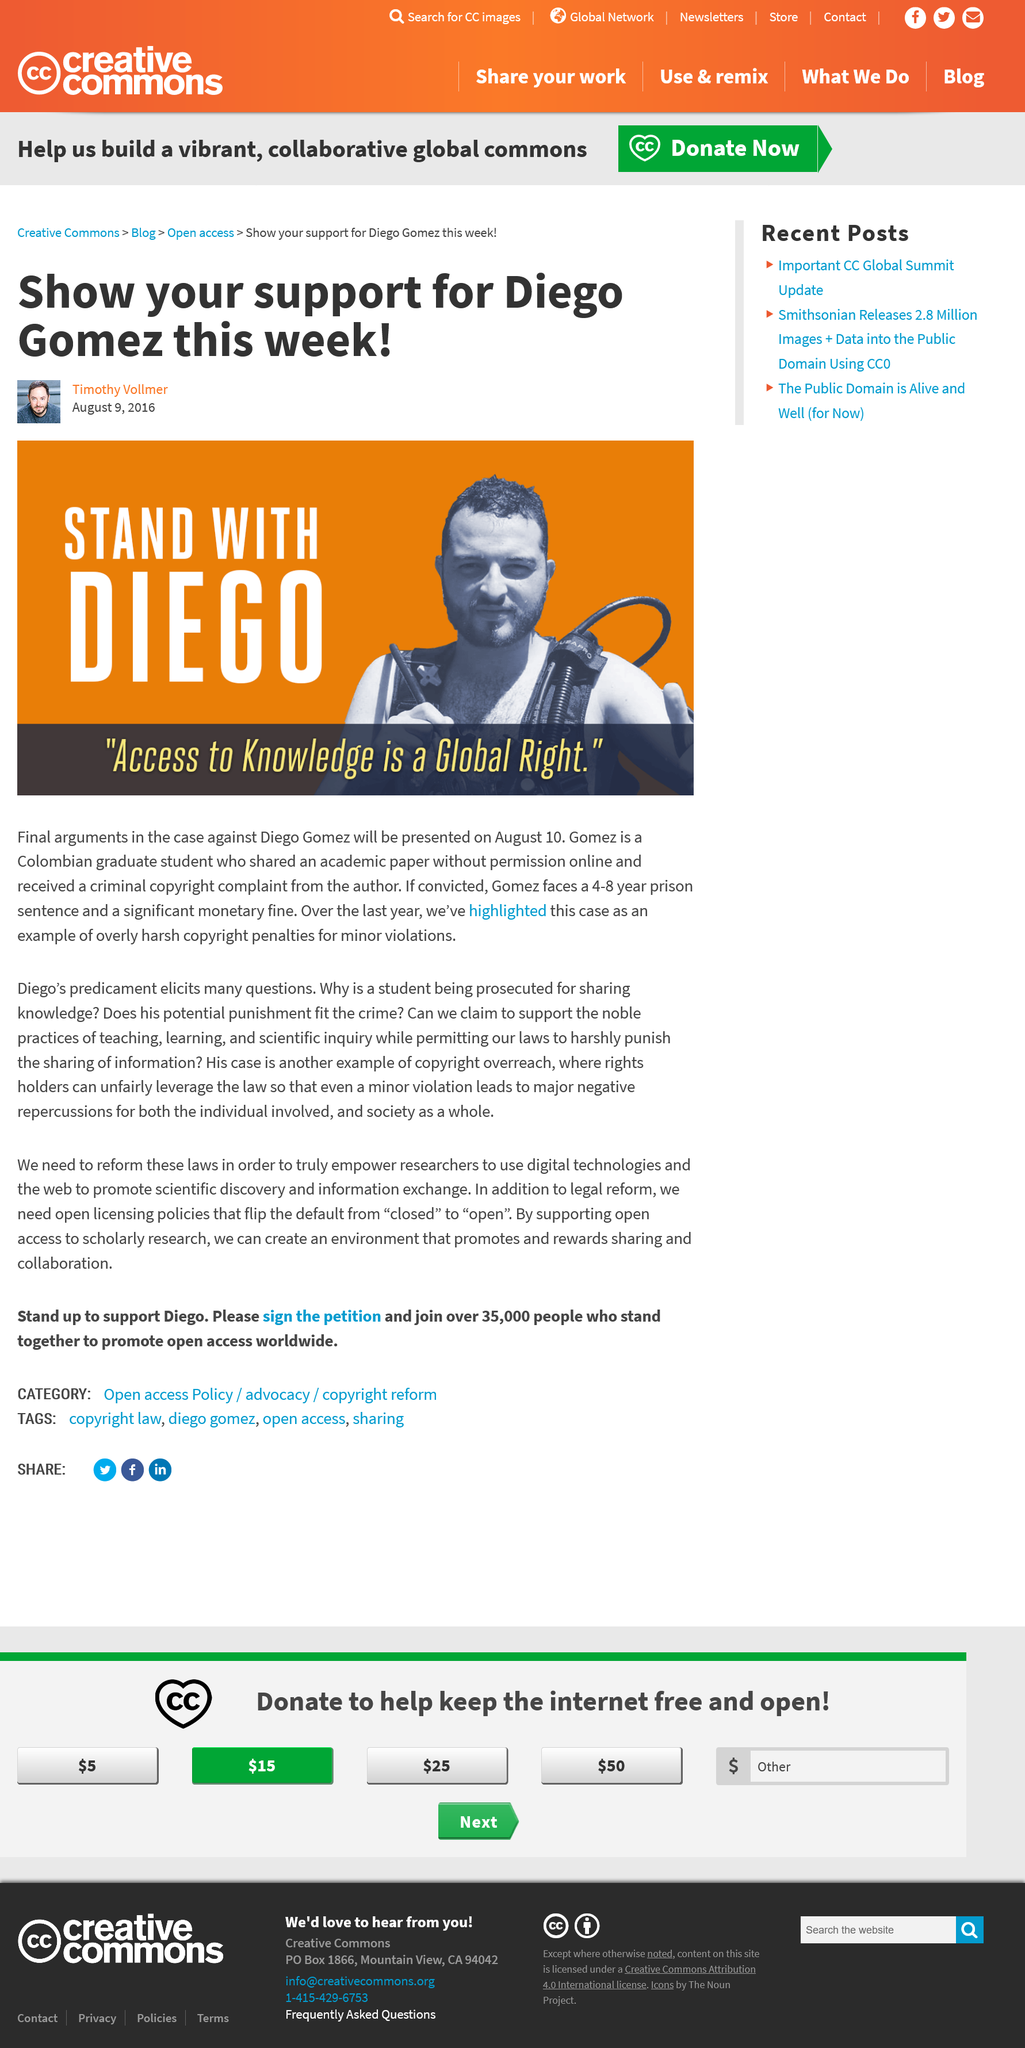Highlight a few significant elements in this photo. Diego Gomez's case is an example of overly harsh copyright penalties for minor violations, which can result in unjust and excessive punishment. Diego Gomez is facing charges for sharing an academic paper without permission online and receiving a copyright complaint. We should provide support to Diego Gomez because it is our moral duty to showcase our knowledge and question the appropriateness of his punishment in light of copyright law. 